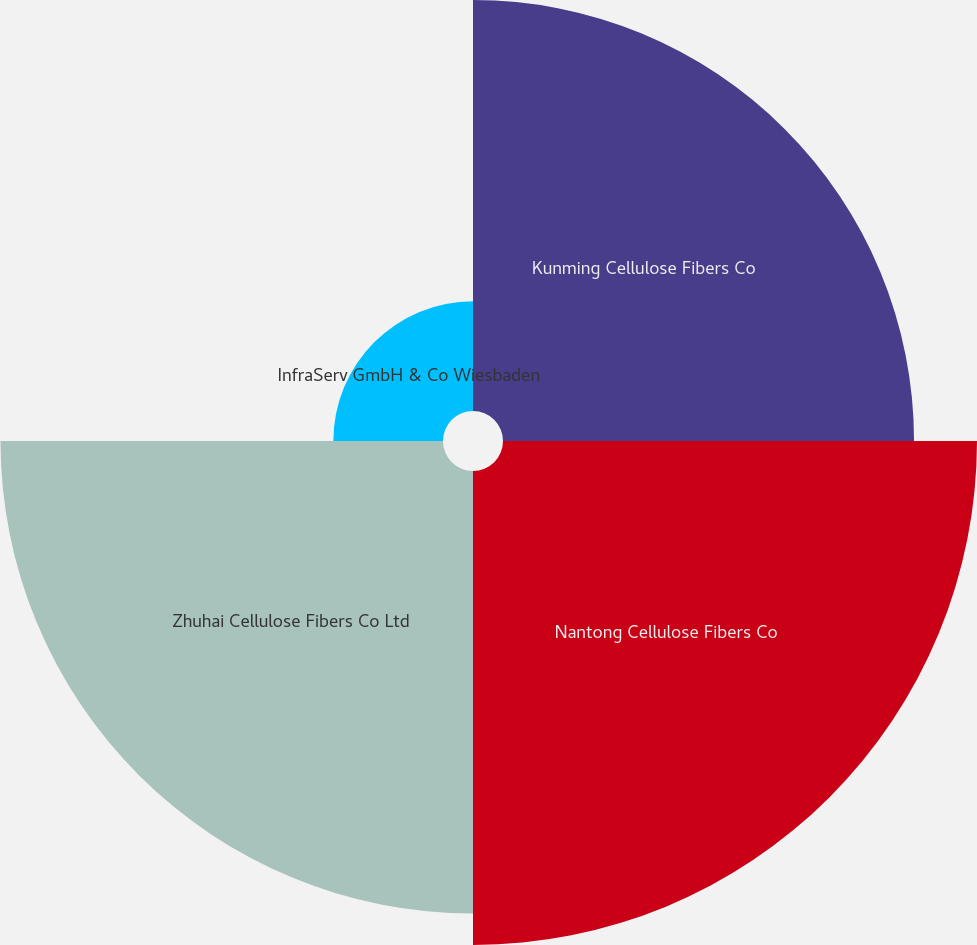<chart> <loc_0><loc_0><loc_500><loc_500><pie_chart><fcel>Kunming Cellulose Fibers Co<fcel>Nantong Cellulose Fibers Co<fcel>Zhuhai Cellulose Fibers Co Ltd<fcel>InfraServ GmbH & Co Wiesbaden<nl><fcel>28.6%<fcel>32.98%<fcel>30.79%<fcel>7.63%<nl></chart> 